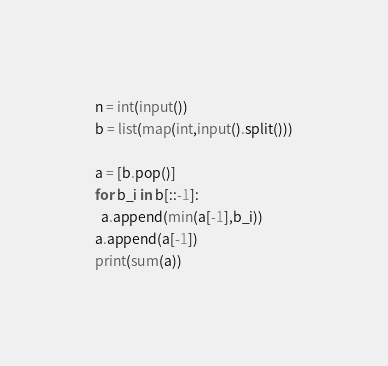Convert code to text. <code><loc_0><loc_0><loc_500><loc_500><_Python_>n = int(input())
b = list(map(int,input().split()))

a = [b.pop()]
for b_i in b[::-1]:
  a.append(min(a[-1],b_i))
a.append(a[-1])
print(sum(a))
</code> 